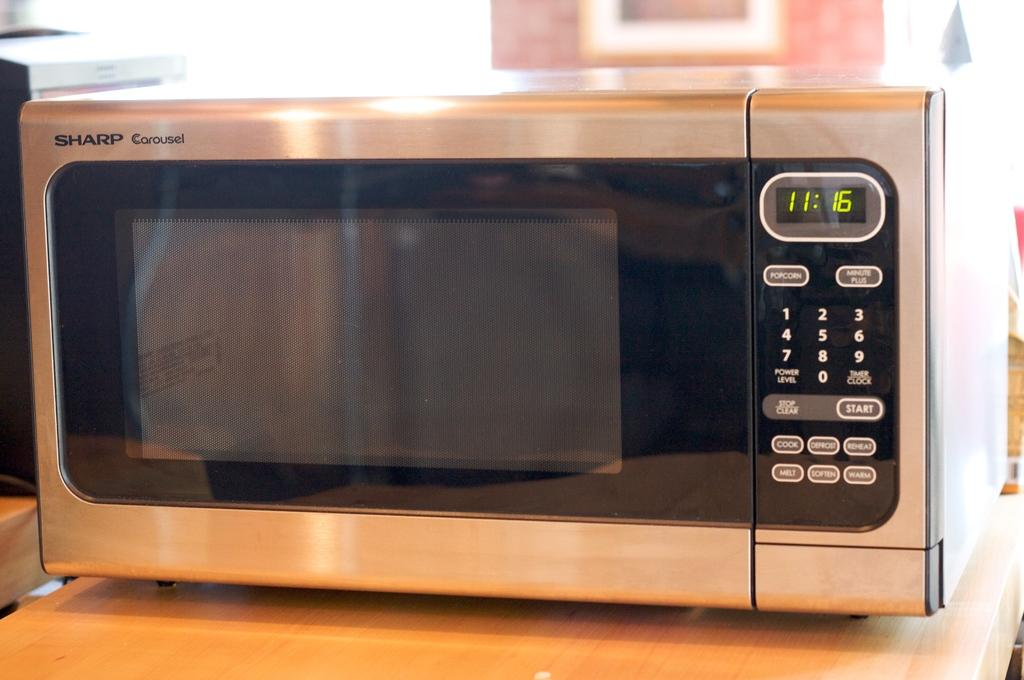What type of appliance is visible in the image? There is an oven in the image. What is the oven placed on? The oven is on a wooden surface. Can you describe the background of the image? The background of the image is blurred. What type of humor can be seen in the image? There is no humor present in the image; it features an oven on a wooden surface with a blurred background. 